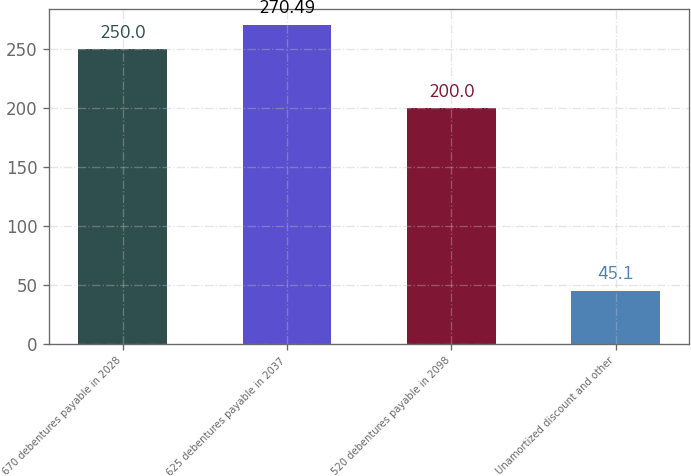Convert chart. <chart><loc_0><loc_0><loc_500><loc_500><bar_chart><fcel>670 debentures payable in 2028<fcel>625 debentures payable in 2037<fcel>520 debentures payable in 2098<fcel>Unamortized discount and other<nl><fcel>250<fcel>270.49<fcel>200<fcel>45.1<nl></chart> 